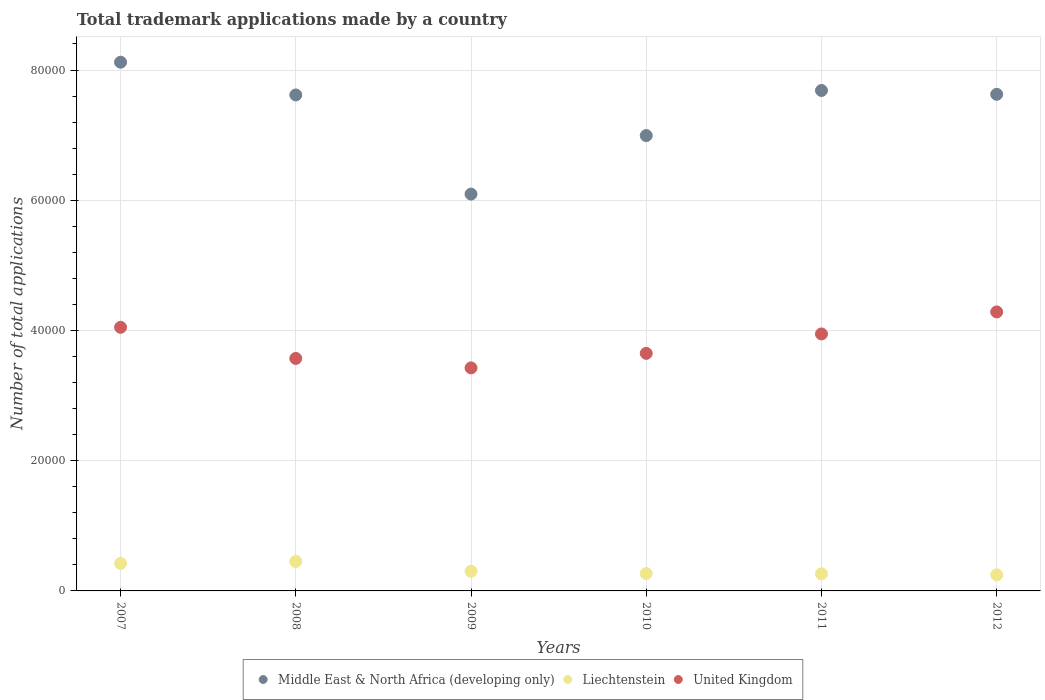How many different coloured dotlines are there?
Your response must be concise. 3. What is the number of applications made by in Middle East & North Africa (developing only) in 2008?
Your response must be concise. 7.62e+04. Across all years, what is the maximum number of applications made by in United Kingdom?
Provide a short and direct response. 4.28e+04. Across all years, what is the minimum number of applications made by in United Kingdom?
Provide a succinct answer. 3.43e+04. In which year was the number of applications made by in United Kingdom maximum?
Make the answer very short. 2012. What is the total number of applications made by in Liechtenstein in the graph?
Ensure brevity in your answer.  1.96e+04. What is the difference between the number of applications made by in Middle East & North Africa (developing only) in 2008 and that in 2009?
Make the answer very short. 1.52e+04. What is the difference between the number of applications made by in United Kingdom in 2009 and the number of applications made by in Liechtenstein in 2010?
Make the answer very short. 3.16e+04. What is the average number of applications made by in Liechtenstein per year?
Keep it short and to the point. 3260.67. In the year 2010, what is the difference between the number of applications made by in Liechtenstein and number of applications made by in Middle East & North Africa (developing only)?
Your response must be concise. -6.73e+04. In how many years, is the number of applications made by in United Kingdom greater than 52000?
Provide a succinct answer. 0. What is the ratio of the number of applications made by in Middle East & North Africa (developing only) in 2011 to that in 2012?
Offer a terse response. 1.01. What is the difference between the highest and the second highest number of applications made by in United Kingdom?
Offer a terse response. 2364. What is the difference between the highest and the lowest number of applications made by in Liechtenstein?
Provide a succinct answer. 2041. In how many years, is the number of applications made by in Middle East & North Africa (developing only) greater than the average number of applications made by in Middle East & North Africa (developing only) taken over all years?
Ensure brevity in your answer.  4. Is the sum of the number of applications made by in Middle East & North Africa (developing only) in 2009 and 2011 greater than the maximum number of applications made by in Liechtenstein across all years?
Your answer should be compact. Yes. Is it the case that in every year, the sum of the number of applications made by in Liechtenstein and number of applications made by in United Kingdom  is greater than the number of applications made by in Middle East & North Africa (developing only)?
Keep it short and to the point. No. Does the number of applications made by in Liechtenstein monotonically increase over the years?
Keep it short and to the point. No. Is the number of applications made by in Liechtenstein strictly greater than the number of applications made by in United Kingdom over the years?
Provide a short and direct response. No. Is the number of applications made by in United Kingdom strictly less than the number of applications made by in Middle East & North Africa (developing only) over the years?
Offer a very short reply. Yes. How many dotlines are there?
Keep it short and to the point. 3. What is the difference between two consecutive major ticks on the Y-axis?
Keep it short and to the point. 2.00e+04. Does the graph contain any zero values?
Make the answer very short. No. Does the graph contain grids?
Give a very brief answer. Yes. How many legend labels are there?
Your response must be concise. 3. What is the title of the graph?
Ensure brevity in your answer.  Total trademark applications made by a country. Does "Eritrea" appear as one of the legend labels in the graph?
Keep it short and to the point. No. What is the label or title of the Y-axis?
Ensure brevity in your answer.  Number of total applications. What is the Number of total applications of Middle East & North Africa (developing only) in 2007?
Offer a terse response. 8.12e+04. What is the Number of total applications in Liechtenstein in 2007?
Make the answer very short. 4228. What is the Number of total applications in United Kingdom in 2007?
Your response must be concise. 4.05e+04. What is the Number of total applications in Middle East & North Africa (developing only) in 2008?
Provide a succinct answer. 7.62e+04. What is the Number of total applications of Liechtenstein in 2008?
Ensure brevity in your answer.  4524. What is the Number of total applications of United Kingdom in 2008?
Keep it short and to the point. 3.57e+04. What is the Number of total applications of Middle East & North Africa (developing only) in 2009?
Offer a very short reply. 6.09e+04. What is the Number of total applications of Liechtenstein in 2009?
Your response must be concise. 3021. What is the Number of total applications in United Kingdom in 2009?
Give a very brief answer. 3.43e+04. What is the Number of total applications in Middle East & North Africa (developing only) in 2010?
Your response must be concise. 6.99e+04. What is the Number of total applications in Liechtenstein in 2010?
Your response must be concise. 2678. What is the Number of total applications of United Kingdom in 2010?
Your response must be concise. 3.65e+04. What is the Number of total applications in Middle East & North Africa (developing only) in 2011?
Your answer should be very brief. 7.69e+04. What is the Number of total applications of Liechtenstein in 2011?
Your answer should be compact. 2630. What is the Number of total applications of United Kingdom in 2011?
Offer a very short reply. 3.95e+04. What is the Number of total applications in Middle East & North Africa (developing only) in 2012?
Provide a succinct answer. 7.63e+04. What is the Number of total applications in Liechtenstein in 2012?
Ensure brevity in your answer.  2483. What is the Number of total applications of United Kingdom in 2012?
Offer a very short reply. 4.28e+04. Across all years, what is the maximum Number of total applications in Middle East & North Africa (developing only)?
Ensure brevity in your answer.  8.12e+04. Across all years, what is the maximum Number of total applications in Liechtenstein?
Offer a very short reply. 4524. Across all years, what is the maximum Number of total applications in United Kingdom?
Your response must be concise. 4.28e+04. Across all years, what is the minimum Number of total applications of Middle East & North Africa (developing only)?
Your answer should be very brief. 6.09e+04. Across all years, what is the minimum Number of total applications of Liechtenstein?
Make the answer very short. 2483. Across all years, what is the minimum Number of total applications of United Kingdom?
Make the answer very short. 3.43e+04. What is the total Number of total applications of Middle East & North Africa (developing only) in the graph?
Keep it short and to the point. 4.41e+05. What is the total Number of total applications of Liechtenstein in the graph?
Ensure brevity in your answer.  1.96e+04. What is the total Number of total applications in United Kingdom in the graph?
Ensure brevity in your answer.  2.29e+05. What is the difference between the Number of total applications in Middle East & North Africa (developing only) in 2007 and that in 2008?
Offer a very short reply. 5029. What is the difference between the Number of total applications of Liechtenstein in 2007 and that in 2008?
Give a very brief answer. -296. What is the difference between the Number of total applications of United Kingdom in 2007 and that in 2008?
Your answer should be very brief. 4779. What is the difference between the Number of total applications in Middle East & North Africa (developing only) in 2007 and that in 2009?
Give a very brief answer. 2.03e+04. What is the difference between the Number of total applications of Liechtenstein in 2007 and that in 2009?
Make the answer very short. 1207. What is the difference between the Number of total applications in United Kingdom in 2007 and that in 2009?
Make the answer very short. 6231. What is the difference between the Number of total applications of Middle East & North Africa (developing only) in 2007 and that in 2010?
Your response must be concise. 1.13e+04. What is the difference between the Number of total applications of Liechtenstein in 2007 and that in 2010?
Your answer should be very brief. 1550. What is the difference between the Number of total applications of United Kingdom in 2007 and that in 2010?
Offer a terse response. 4000. What is the difference between the Number of total applications in Middle East & North Africa (developing only) in 2007 and that in 2011?
Provide a short and direct response. 4343. What is the difference between the Number of total applications of Liechtenstein in 2007 and that in 2011?
Offer a terse response. 1598. What is the difference between the Number of total applications in United Kingdom in 2007 and that in 2011?
Offer a terse response. 1017. What is the difference between the Number of total applications in Middle East & North Africa (developing only) in 2007 and that in 2012?
Your answer should be very brief. 4931. What is the difference between the Number of total applications in Liechtenstein in 2007 and that in 2012?
Your answer should be very brief. 1745. What is the difference between the Number of total applications in United Kingdom in 2007 and that in 2012?
Keep it short and to the point. -2364. What is the difference between the Number of total applications of Middle East & North Africa (developing only) in 2008 and that in 2009?
Your answer should be compact. 1.52e+04. What is the difference between the Number of total applications in Liechtenstein in 2008 and that in 2009?
Your answer should be very brief. 1503. What is the difference between the Number of total applications in United Kingdom in 2008 and that in 2009?
Your response must be concise. 1452. What is the difference between the Number of total applications of Middle East & North Africa (developing only) in 2008 and that in 2010?
Ensure brevity in your answer.  6241. What is the difference between the Number of total applications in Liechtenstein in 2008 and that in 2010?
Provide a short and direct response. 1846. What is the difference between the Number of total applications of United Kingdom in 2008 and that in 2010?
Offer a very short reply. -779. What is the difference between the Number of total applications in Middle East & North Africa (developing only) in 2008 and that in 2011?
Provide a short and direct response. -686. What is the difference between the Number of total applications in Liechtenstein in 2008 and that in 2011?
Offer a very short reply. 1894. What is the difference between the Number of total applications of United Kingdom in 2008 and that in 2011?
Provide a succinct answer. -3762. What is the difference between the Number of total applications in Middle East & North Africa (developing only) in 2008 and that in 2012?
Offer a terse response. -98. What is the difference between the Number of total applications in Liechtenstein in 2008 and that in 2012?
Offer a terse response. 2041. What is the difference between the Number of total applications in United Kingdom in 2008 and that in 2012?
Offer a terse response. -7143. What is the difference between the Number of total applications of Middle East & North Africa (developing only) in 2009 and that in 2010?
Provide a short and direct response. -8987. What is the difference between the Number of total applications of Liechtenstein in 2009 and that in 2010?
Make the answer very short. 343. What is the difference between the Number of total applications in United Kingdom in 2009 and that in 2010?
Offer a very short reply. -2231. What is the difference between the Number of total applications of Middle East & North Africa (developing only) in 2009 and that in 2011?
Your answer should be compact. -1.59e+04. What is the difference between the Number of total applications in Liechtenstein in 2009 and that in 2011?
Give a very brief answer. 391. What is the difference between the Number of total applications in United Kingdom in 2009 and that in 2011?
Make the answer very short. -5214. What is the difference between the Number of total applications of Middle East & North Africa (developing only) in 2009 and that in 2012?
Your response must be concise. -1.53e+04. What is the difference between the Number of total applications in Liechtenstein in 2009 and that in 2012?
Provide a succinct answer. 538. What is the difference between the Number of total applications in United Kingdom in 2009 and that in 2012?
Offer a very short reply. -8595. What is the difference between the Number of total applications of Middle East & North Africa (developing only) in 2010 and that in 2011?
Your response must be concise. -6927. What is the difference between the Number of total applications of Liechtenstein in 2010 and that in 2011?
Your answer should be very brief. 48. What is the difference between the Number of total applications of United Kingdom in 2010 and that in 2011?
Keep it short and to the point. -2983. What is the difference between the Number of total applications of Middle East & North Africa (developing only) in 2010 and that in 2012?
Offer a terse response. -6339. What is the difference between the Number of total applications in Liechtenstein in 2010 and that in 2012?
Your answer should be compact. 195. What is the difference between the Number of total applications of United Kingdom in 2010 and that in 2012?
Offer a very short reply. -6364. What is the difference between the Number of total applications in Middle East & North Africa (developing only) in 2011 and that in 2012?
Give a very brief answer. 588. What is the difference between the Number of total applications of Liechtenstein in 2011 and that in 2012?
Keep it short and to the point. 147. What is the difference between the Number of total applications in United Kingdom in 2011 and that in 2012?
Make the answer very short. -3381. What is the difference between the Number of total applications of Middle East & North Africa (developing only) in 2007 and the Number of total applications of Liechtenstein in 2008?
Provide a short and direct response. 7.67e+04. What is the difference between the Number of total applications of Middle East & North Africa (developing only) in 2007 and the Number of total applications of United Kingdom in 2008?
Your answer should be very brief. 4.55e+04. What is the difference between the Number of total applications of Liechtenstein in 2007 and the Number of total applications of United Kingdom in 2008?
Your answer should be compact. -3.15e+04. What is the difference between the Number of total applications of Middle East & North Africa (developing only) in 2007 and the Number of total applications of Liechtenstein in 2009?
Make the answer very short. 7.82e+04. What is the difference between the Number of total applications of Middle East & North Africa (developing only) in 2007 and the Number of total applications of United Kingdom in 2009?
Make the answer very short. 4.69e+04. What is the difference between the Number of total applications of Liechtenstein in 2007 and the Number of total applications of United Kingdom in 2009?
Make the answer very short. -3.00e+04. What is the difference between the Number of total applications of Middle East & North Africa (developing only) in 2007 and the Number of total applications of Liechtenstein in 2010?
Offer a terse response. 7.85e+04. What is the difference between the Number of total applications in Middle East & North Africa (developing only) in 2007 and the Number of total applications in United Kingdom in 2010?
Offer a terse response. 4.47e+04. What is the difference between the Number of total applications in Liechtenstein in 2007 and the Number of total applications in United Kingdom in 2010?
Offer a very short reply. -3.23e+04. What is the difference between the Number of total applications of Middle East & North Africa (developing only) in 2007 and the Number of total applications of Liechtenstein in 2011?
Your answer should be compact. 7.86e+04. What is the difference between the Number of total applications in Middle East & North Africa (developing only) in 2007 and the Number of total applications in United Kingdom in 2011?
Provide a succinct answer. 4.17e+04. What is the difference between the Number of total applications of Liechtenstein in 2007 and the Number of total applications of United Kingdom in 2011?
Offer a terse response. -3.52e+04. What is the difference between the Number of total applications in Middle East & North Africa (developing only) in 2007 and the Number of total applications in Liechtenstein in 2012?
Keep it short and to the point. 7.87e+04. What is the difference between the Number of total applications of Middle East & North Africa (developing only) in 2007 and the Number of total applications of United Kingdom in 2012?
Provide a short and direct response. 3.84e+04. What is the difference between the Number of total applications of Liechtenstein in 2007 and the Number of total applications of United Kingdom in 2012?
Ensure brevity in your answer.  -3.86e+04. What is the difference between the Number of total applications in Middle East & North Africa (developing only) in 2008 and the Number of total applications in Liechtenstein in 2009?
Offer a terse response. 7.31e+04. What is the difference between the Number of total applications of Middle East & North Africa (developing only) in 2008 and the Number of total applications of United Kingdom in 2009?
Give a very brief answer. 4.19e+04. What is the difference between the Number of total applications in Liechtenstein in 2008 and the Number of total applications in United Kingdom in 2009?
Provide a succinct answer. -2.97e+04. What is the difference between the Number of total applications of Middle East & North Africa (developing only) in 2008 and the Number of total applications of Liechtenstein in 2010?
Provide a succinct answer. 7.35e+04. What is the difference between the Number of total applications in Middle East & North Africa (developing only) in 2008 and the Number of total applications in United Kingdom in 2010?
Make the answer very short. 3.97e+04. What is the difference between the Number of total applications in Liechtenstein in 2008 and the Number of total applications in United Kingdom in 2010?
Your answer should be very brief. -3.20e+04. What is the difference between the Number of total applications in Middle East & North Africa (developing only) in 2008 and the Number of total applications in Liechtenstein in 2011?
Give a very brief answer. 7.35e+04. What is the difference between the Number of total applications in Middle East & North Africa (developing only) in 2008 and the Number of total applications in United Kingdom in 2011?
Provide a succinct answer. 3.67e+04. What is the difference between the Number of total applications of Liechtenstein in 2008 and the Number of total applications of United Kingdom in 2011?
Make the answer very short. -3.49e+04. What is the difference between the Number of total applications of Middle East & North Africa (developing only) in 2008 and the Number of total applications of Liechtenstein in 2012?
Provide a short and direct response. 7.37e+04. What is the difference between the Number of total applications in Middle East & North Africa (developing only) in 2008 and the Number of total applications in United Kingdom in 2012?
Offer a very short reply. 3.33e+04. What is the difference between the Number of total applications of Liechtenstein in 2008 and the Number of total applications of United Kingdom in 2012?
Provide a succinct answer. -3.83e+04. What is the difference between the Number of total applications in Middle East & North Africa (developing only) in 2009 and the Number of total applications in Liechtenstein in 2010?
Ensure brevity in your answer.  5.83e+04. What is the difference between the Number of total applications of Middle East & North Africa (developing only) in 2009 and the Number of total applications of United Kingdom in 2010?
Provide a succinct answer. 2.45e+04. What is the difference between the Number of total applications in Liechtenstein in 2009 and the Number of total applications in United Kingdom in 2010?
Offer a terse response. -3.35e+04. What is the difference between the Number of total applications of Middle East & North Africa (developing only) in 2009 and the Number of total applications of Liechtenstein in 2011?
Ensure brevity in your answer.  5.83e+04. What is the difference between the Number of total applications in Middle East & North Africa (developing only) in 2009 and the Number of total applications in United Kingdom in 2011?
Keep it short and to the point. 2.15e+04. What is the difference between the Number of total applications in Liechtenstein in 2009 and the Number of total applications in United Kingdom in 2011?
Give a very brief answer. -3.64e+04. What is the difference between the Number of total applications of Middle East & North Africa (developing only) in 2009 and the Number of total applications of Liechtenstein in 2012?
Make the answer very short. 5.85e+04. What is the difference between the Number of total applications of Middle East & North Africa (developing only) in 2009 and the Number of total applications of United Kingdom in 2012?
Your response must be concise. 1.81e+04. What is the difference between the Number of total applications in Liechtenstein in 2009 and the Number of total applications in United Kingdom in 2012?
Ensure brevity in your answer.  -3.98e+04. What is the difference between the Number of total applications of Middle East & North Africa (developing only) in 2010 and the Number of total applications of Liechtenstein in 2011?
Give a very brief answer. 6.73e+04. What is the difference between the Number of total applications in Middle East & North Africa (developing only) in 2010 and the Number of total applications in United Kingdom in 2011?
Keep it short and to the point. 3.05e+04. What is the difference between the Number of total applications of Liechtenstein in 2010 and the Number of total applications of United Kingdom in 2011?
Keep it short and to the point. -3.68e+04. What is the difference between the Number of total applications of Middle East & North Africa (developing only) in 2010 and the Number of total applications of Liechtenstein in 2012?
Offer a very short reply. 6.74e+04. What is the difference between the Number of total applications in Middle East & North Africa (developing only) in 2010 and the Number of total applications in United Kingdom in 2012?
Offer a very short reply. 2.71e+04. What is the difference between the Number of total applications of Liechtenstein in 2010 and the Number of total applications of United Kingdom in 2012?
Ensure brevity in your answer.  -4.02e+04. What is the difference between the Number of total applications in Middle East & North Africa (developing only) in 2011 and the Number of total applications in Liechtenstein in 2012?
Keep it short and to the point. 7.44e+04. What is the difference between the Number of total applications in Middle East & North Africa (developing only) in 2011 and the Number of total applications in United Kingdom in 2012?
Ensure brevity in your answer.  3.40e+04. What is the difference between the Number of total applications of Liechtenstein in 2011 and the Number of total applications of United Kingdom in 2012?
Keep it short and to the point. -4.02e+04. What is the average Number of total applications in Middle East & North Africa (developing only) per year?
Provide a short and direct response. 7.36e+04. What is the average Number of total applications of Liechtenstein per year?
Make the answer very short. 3260.67. What is the average Number of total applications of United Kingdom per year?
Make the answer very short. 3.82e+04. In the year 2007, what is the difference between the Number of total applications in Middle East & North Africa (developing only) and Number of total applications in Liechtenstein?
Your answer should be very brief. 7.70e+04. In the year 2007, what is the difference between the Number of total applications in Middle East & North Africa (developing only) and Number of total applications in United Kingdom?
Offer a very short reply. 4.07e+04. In the year 2007, what is the difference between the Number of total applications in Liechtenstein and Number of total applications in United Kingdom?
Your response must be concise. -3.63e+04. In the year 2008, what is the difference between the Number of total applications in Middle East & North Africa (developing only) and Number of total applications in Liechtenstein?
Ensure brevity in your answer.  7.16e+04. In the year 2008, what is the difference between the Number of total applications of Middle East & North Africa (developing only) and Number of total applications of United Kingdom?
Offer a very short reply. 4.05e+04. In the year 2008, what is the difference between the Number of total applications in Liechtenstein and Number of total applications in United Kingdom?
Provide a short and direct response. -3.12e+04. In the year 2009, what is the difference between the Number of total applications in Middle East & North Africa (developing only) and Number of total applications in Liechtenstein?
Provide a short and direct response. 5.79e+04. In the year 2009, what is the difference between the Number of total applications of Middle East & North Africa (developing only) and Number of total applications of United Kingdom?
Ensure brevity in your answer.  2.67e+04. In the year 2009, what is the difference between the Number of total applications in Liechtenstein and Number of total applications in United Kingdom?
Your answer should be compact. -3.12e+04. In the year 2010, what is the difference between the Number of total applications in Middle East & North Africa (developing only) and Number of total applications in Liechtenstein?
Provide a short and direct response. 6.73e+04. In the year 2010, what is the difference between the Number of total applications of Middle East & North Africa (developing only) and Number of total applications of United Kingdom?
Make the answer very short. 3.34e+04. In the year 2010, what is the difference between the Number of total applications of Liechtenstein and Number of total applications of United Kingdom?
Your response must be concise. -3.38e+04. In the year 2011, what is the difference between the Number of total applications of Middle East & North Africa (developing only) and Number of total applications of Liechtenstein?
Ensure brevity in your answer.  7.42e+04. In the year 2011, what is the difference between the Number of total applications in Middle East & North Africa (developing only) and Number of total applications in United Kingdom?
Keep it short and to the point. 3.74e+04. In the year 2011, what is the difference between the Number of total applications in Liechtenstein and Number of total applications in United Kingdom?
Offer a very short reply. -3.68e+04. In the year 2012, what is the difference between the Number of total applications of Middle East & North Africa (developing only) and Number of total applications of Liechtenstein?
Your answer should be very brief. 7.38e+04. In the year 2012, what is the difference between the Number of total applications of Middle East & North Africa (developing only) and Number of total applications of United Kingdom?
Make the answer very short. 3.34e+04. In the year 2012, what is the difference between the Number of total applications of Liechtenstein and Number of total applications of United Kingdom?
Give a very brief answer. -4.04e+04. What is the ratio of the Number of total applications of Middle East & North Africa (developing only) in 2007 to that in 2008?
Make the answer very short. 1.07. What is the ratio of the Number of total applications of Liechtenstein in 2007 to that in 2008?
Give a very brief answer. 0.93. What is the ratio of the Number of total applications of United Kingdom in 2007 to that in 2008?
Your answer should be very brief. 1.13. What is the ratio of the Number of total applications of Middle East & North Africa (developing only) in 2007 to that in 2009?
Your response must be concise. 1.33. What is the ratio of the Number of total applications in Liechtenstein in 2007 to that in 2009?
Ensure brevity in your answer.  1.4. What is the ratio of the Number of total applications of United Kingdom in 2007 to that in 2009?
Offer a very short reply. 1.18. What is the ratio of the Number of total applications in Middle East & North Africa (developing only) in 2007 to that in 2010?
Keep it short and to the point. 1.16. What is the ratio of the Number of total applications in Liechtenstein in 2007 to that in 2010?
Ensure brevity in your answer.  1.58. What is the ratio of the Number of total applications in United Kingdom in 2007 to that in 2010?
Your answer should be very brief. 1.11. What is the ratio of the Number of total applications in Middle East & North Africa (developing only) in 2007 to that in 2011?
Your response must be concise. 1.06. What is the ratio of the Number of total applications of Liechtenstein in 2007 to that in 2011?
Offer a very short reply. 1.61. What is the ratio of the Number of total applications of United Kingdom in 2007 to that in 2011?
Your answer should be compact. 1.03. What is the ratio of the Number of total applications in Middle East & North Africa (developing only) in 2007 to that in 2012?
Ensure brevity in your answer.  1.06. What is the ratio of the Number of total applications in Liechtenstein in 2007 to that in 2012?
Give a very brief answer. 1.7. What is the ratio of the Number of total applications of United Kingdom in 2007 to that in 2012?
Keep it short and to the point. 0.94. What is the ratio of the Number of total applications of Middle East & North Africa (developing only) in 2008 to that in 2009?
Provide a short and direct response. 1.25. What is the ratio of the Number of total applications in Liechtenstein in 2008 to that in 2009?
Offer a very short reply. 1.5. What is the ratio of the Number of total applications in United Kingdom in 2008 to that in 2009?
Keep it short and to the point. 1.04. What is the ratio of the Number of total applications of Middle East & North Africa (developing only) in 2008 to that in 2010?
Give a very brief answer. 1.09. What is the ratio of the Number of total applications in Liechtenstein in 2008 to that in 2010?
Ensure brevity in your answer.  1.69. What is the ratio of the Number of total applications of United Kingdom in 2008 to that in 2010?
Give a very brief answer. 0.98. What is the ratio of the Number of total applications of Liechtenstein in 2008 to that in 2011?
Give a very brief answer. 1.72. What is the ratio of the Number of total applications of United Kingdom in 2008 to that in 2011?
Your answer should be compact. 0.9. What is the ratio of the Number of total applications in Middle East & North Africa (developing only) in 2008 to that in 2012?
Make the answer very short. 1. What is the ratio of the Number of total applications in Liechtenstein in 2008 to that in 2012?
Keep it short and to the point. 1.82. What is the ratio of the Number of total applications in United Kingdom in 2008 to that in 2012?
Offer a terse response. 0.83. What is the ratio of the Number of total applications of Middle East & North Africa (developing only) in 2009 to that in 2010?
Your answer should be compact. 0.87. What is the ratio of the Number of total applications of Liechtenstein in 2009 to that in 2010?
Your response must be concise. 1.13. What is the ratio of the Number of total applications in United Kingdom in 2009 to that in 2010?
Offer a terse response. 0.94. What is the ratio of the Number of total applications of Middle East & North Africa (developing only) in 2009 to that in 2011?
Keep it short and to the point. 0.79. What is the ratio of the Number of total applications in Liechtenstein in 2009 to that in 2011?
Your response must be concise. 1.15. What is the ratio of the Number of total applications of United Kingdom in 2009 to that in 2011?
Offer a very short reply. 0.87. What is the ratio of the Number of total applications in Middle East & North Africa (developing only) in 2009 to that in 2012?
Offer a very short reply. 0.8. What is the ratio of the Number of total applications in Liechtenstein in 2009 to that in 2012?
Ensure brevity in your answer.  1.22. What is the ratio of the Number of total applications in United Kingdom in 2009 to that in 2012?
Offer a terse response. 0.8. What is the ratio of the Number of total applications in Middle East & North Africa (developing only) in 2010 to that in 2011?
Make the answer very short. 0.91. What is the ratio of the Number of total applications in Liechtenstein in 2010 to that in 2011?
Keep it short and to the point. 1.02. What is the ratio of the Number of total applications in United Kingdom in 2010 to that in 2011?
Provide a short and direct response. 0.92. What is the ratio of the Number of total applications in Middle East & North Africa (developing only) in 2010 to that in 2012?
Provide a short and direct response. 0.92. What is the ratio of the Number of total applications in Liechtenstein in 2010 to that in 2012?
Your answer should be compact. 1.08. What is the ratio of the Number of total applications in United Kingdom in 2010 to that in 2012?
Give a very brief answer. 0.85. What is the ratio of the Number of total applications of Middle East & North Africa (developing only) in 2011 to that in 2012?
Ensure brevity in your answer.  1.01. What is the ratio of the Number of total applications in Liechtenstein in 2011 to that in 2012?
Ensure brevity in your answer.  1.06. What is the ratio of the Number of total applications in United Kingdom in 2011 to that in 2012?
Your response must be concise. 0.92. What is the difference between the highest and the second highest Number of total applications in Middle East & North Africa (developing only)?
Make the answer very short. 4343. What is the difference between the highest and the second highest Number of total applications of Liechtenstein?
Your response must be concise. 296. What is the difference between the highest and the second highest Number of total applications of United Kingdom?
Provide a short and direct response. 2364. What is the difference between the highest and the lowest Number of total applications in Middle East & North Africa (developing only)?
Provide a short and direct response. 2.03e+04. What is the difference between the highest and the lowest Number of total applications in Liechtenstein?
Provide a succinct answer. 2041. What is the difference between the highest and the lowest Number of total applications in United Kingdom?
Offer a very short reply. 8595. 